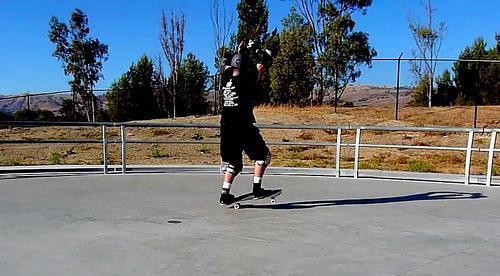How many people are there?
Give a very brief answer. 1. 